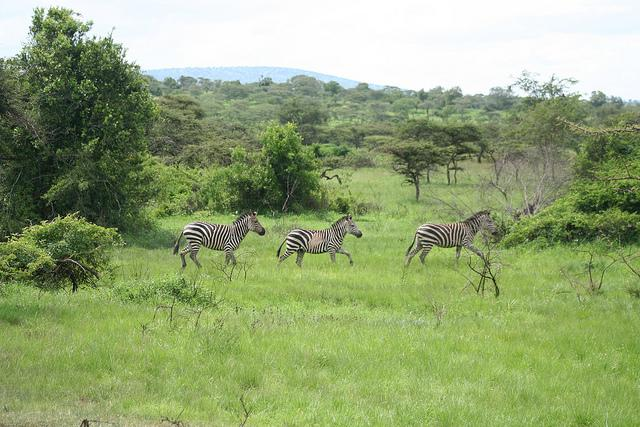What place are the zebra in? Please explain your reasoning. wilderness. They're in the wild. 